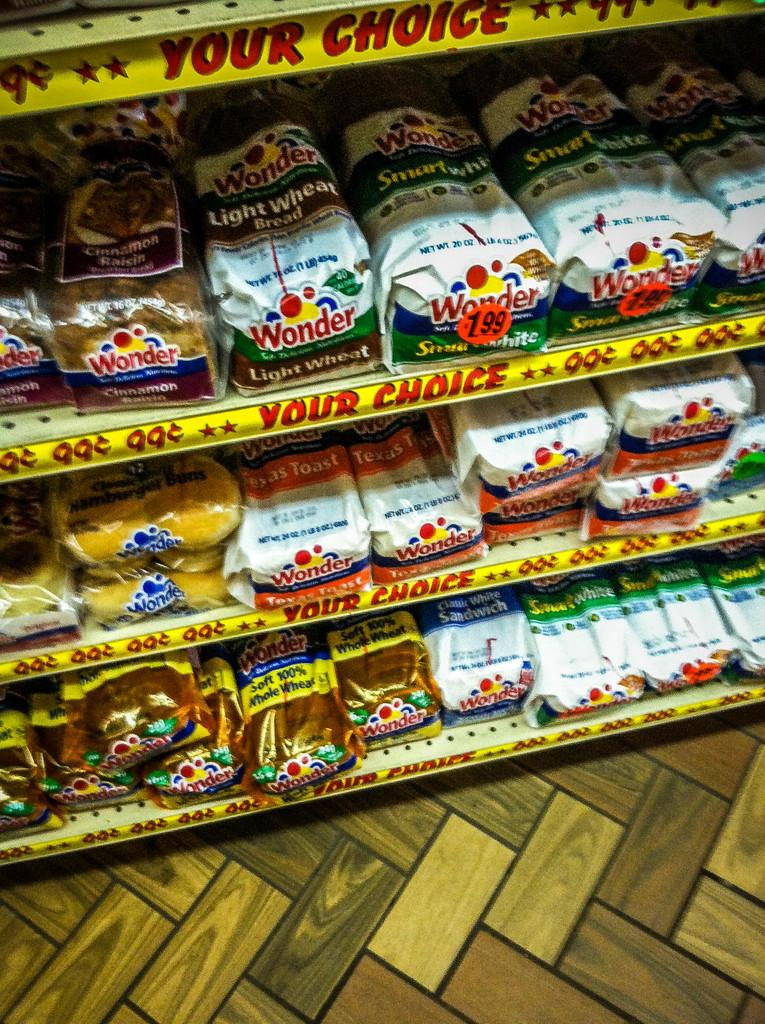<image>
Summarize the visual content of the image. shelves in a store that have wonder light wheat bread on it 